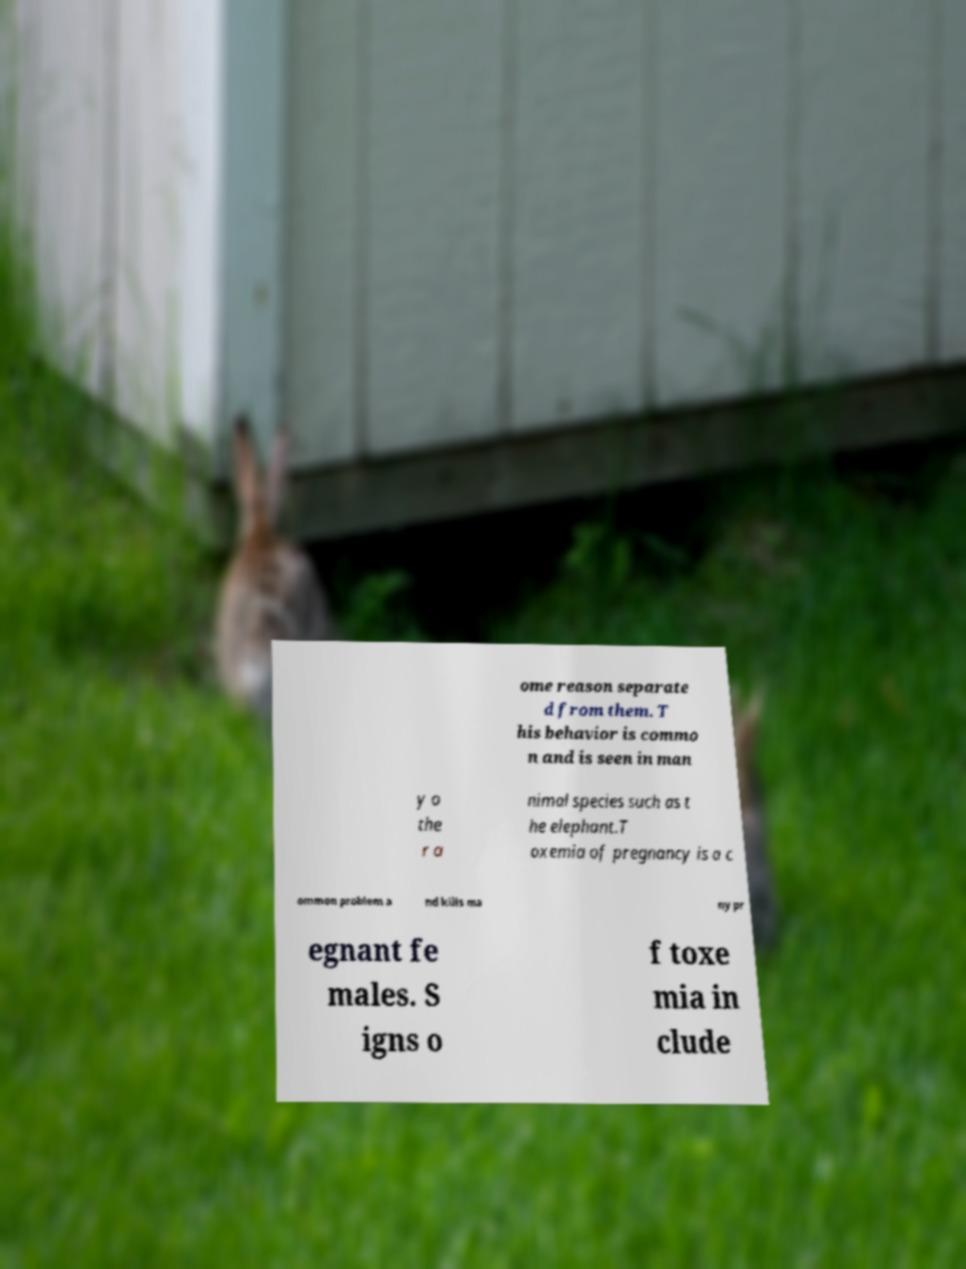For documentation purposes, I need the text within this image transcribed. Could you provide that? ome reason separate d from them. T his behavior is commo n and is seen in man y o the r a nimal species such as t he elephant.T oxemia of pregnancy is a c ommon problem a nd kills ma ny pr egnant fe males. S igns o f toxe mia in clude 